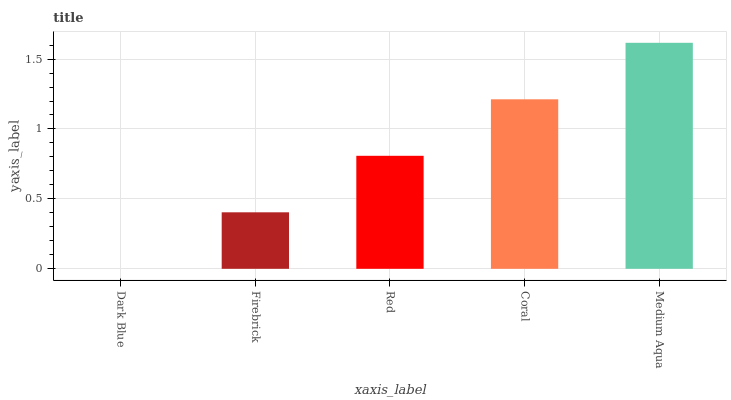Is Firebrick the minimum?
Answer yes or no. No. Is Firebrick the maximum?
Answer yes or no. No. Is Firebrick greater than Dark Blue?
Answer yes or no. Yes. Is Dark Blue less than Firebrick?
Answer yes or no. Yes. Is Dark Blue greater than Firebrick?
Answer yes or no. No. Is Firebrick less than Dark Blue?
Answer yes or no. No. Is Red the high median?
Answer yes or no. Yes. Is Red the low median?
Answer yes or no. Yes. Is Dark Blue the high median?
Answer yes or no. No. Is Dark Blue the low median?
Answer yes or no. No. 